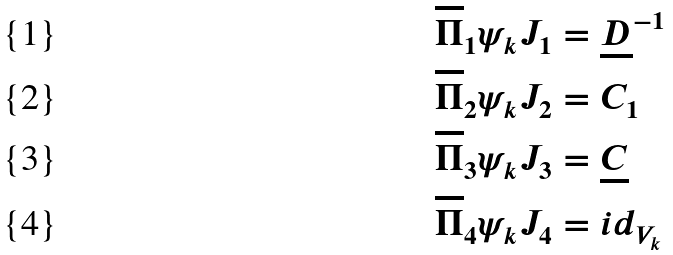Convert formula to latex. <formula><loc_0><loc_0><loc_500><loc_500>\overline { \Pi } _ { 1 } \psi _ { k } J _ { 1 } & = \underline { D } ^ { - 1 } \\ \overline { \Pi } _ { 2 } \psi _ { k } J _ { 2 } & = C _ { 1 } \\ \overline { \Pi } _ { 3 } \psi _ { k } J _ { 3 } & = \underline { C } \\ \overline { \Pi } _ { 4 } \psi _ { k } J _ { 4 } & = i d _ { V _ { k } }</formula> 